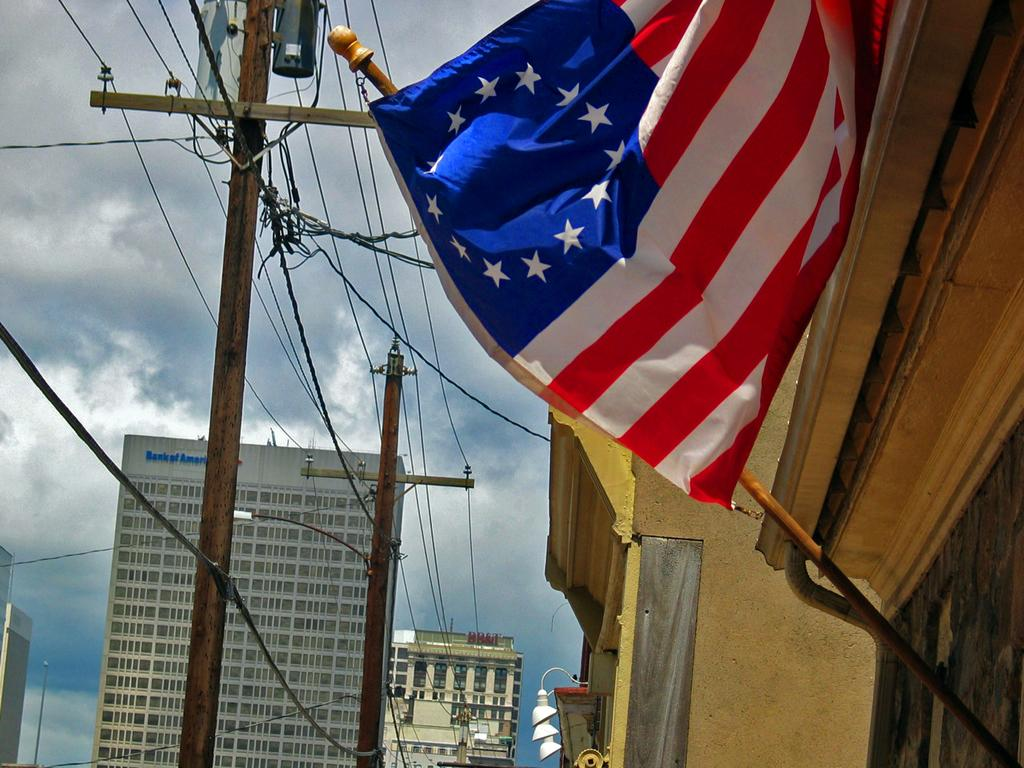What can be seen in the image that represents a symbol or country? There is a flag in the image that represents a symbol or country. Where is the flag located in the image? The flag is attached to a building in the image. Which side of the image does the building with the flag appear on? The building with the flag is on the right side of the image. What other structures can be seen in front of the building with the flag? There are electric poles in front of the building with the flag. What is visible in the background of the image? There are buildings in the background of the image. What can be seen in the sky in the image? The sky is visible in the image, and clouds are present. Can you see a letter being written by a squirrel on a print in the image? No, there is no letter, squirrel, or print present in the image. 